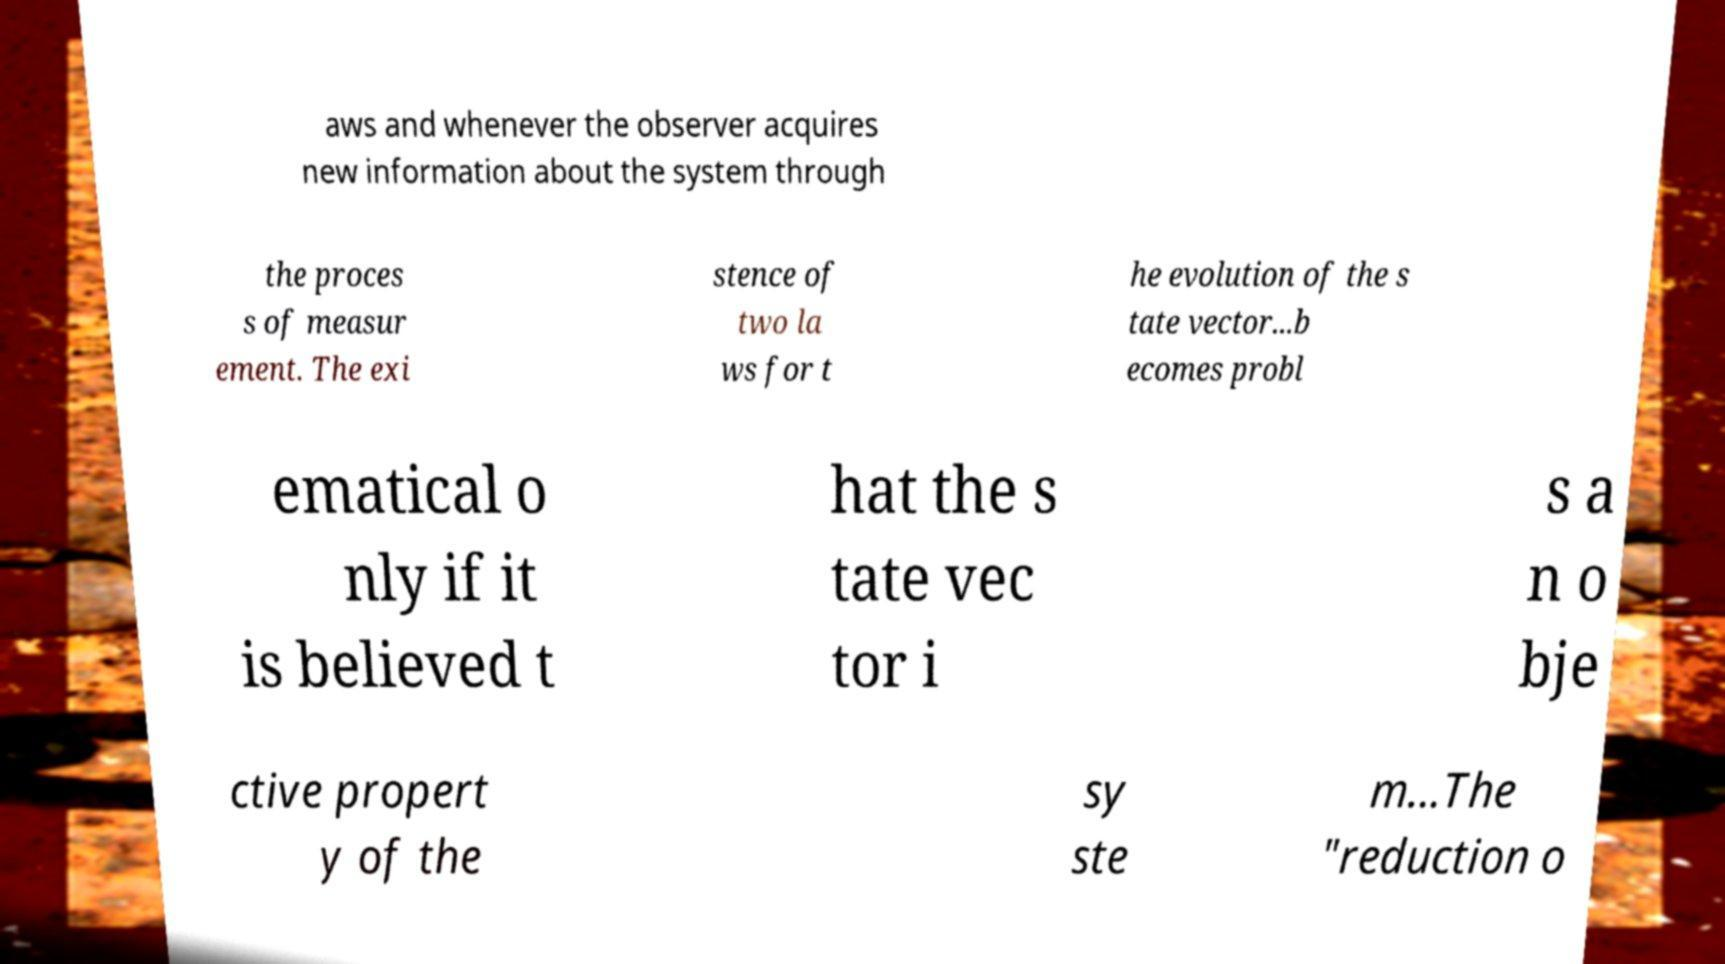Could you extract and type out the text from this image? aws and whenever the observer acquires new information about the system through the proces s of measur ement. The exi stence of two la ws for t he evolution of the s tate vector...b ecomes probl ematical o nly if it is believed t hat the s tate vec tor i s a n o bje ctive propert y of the sy ste m...The "reduction o 